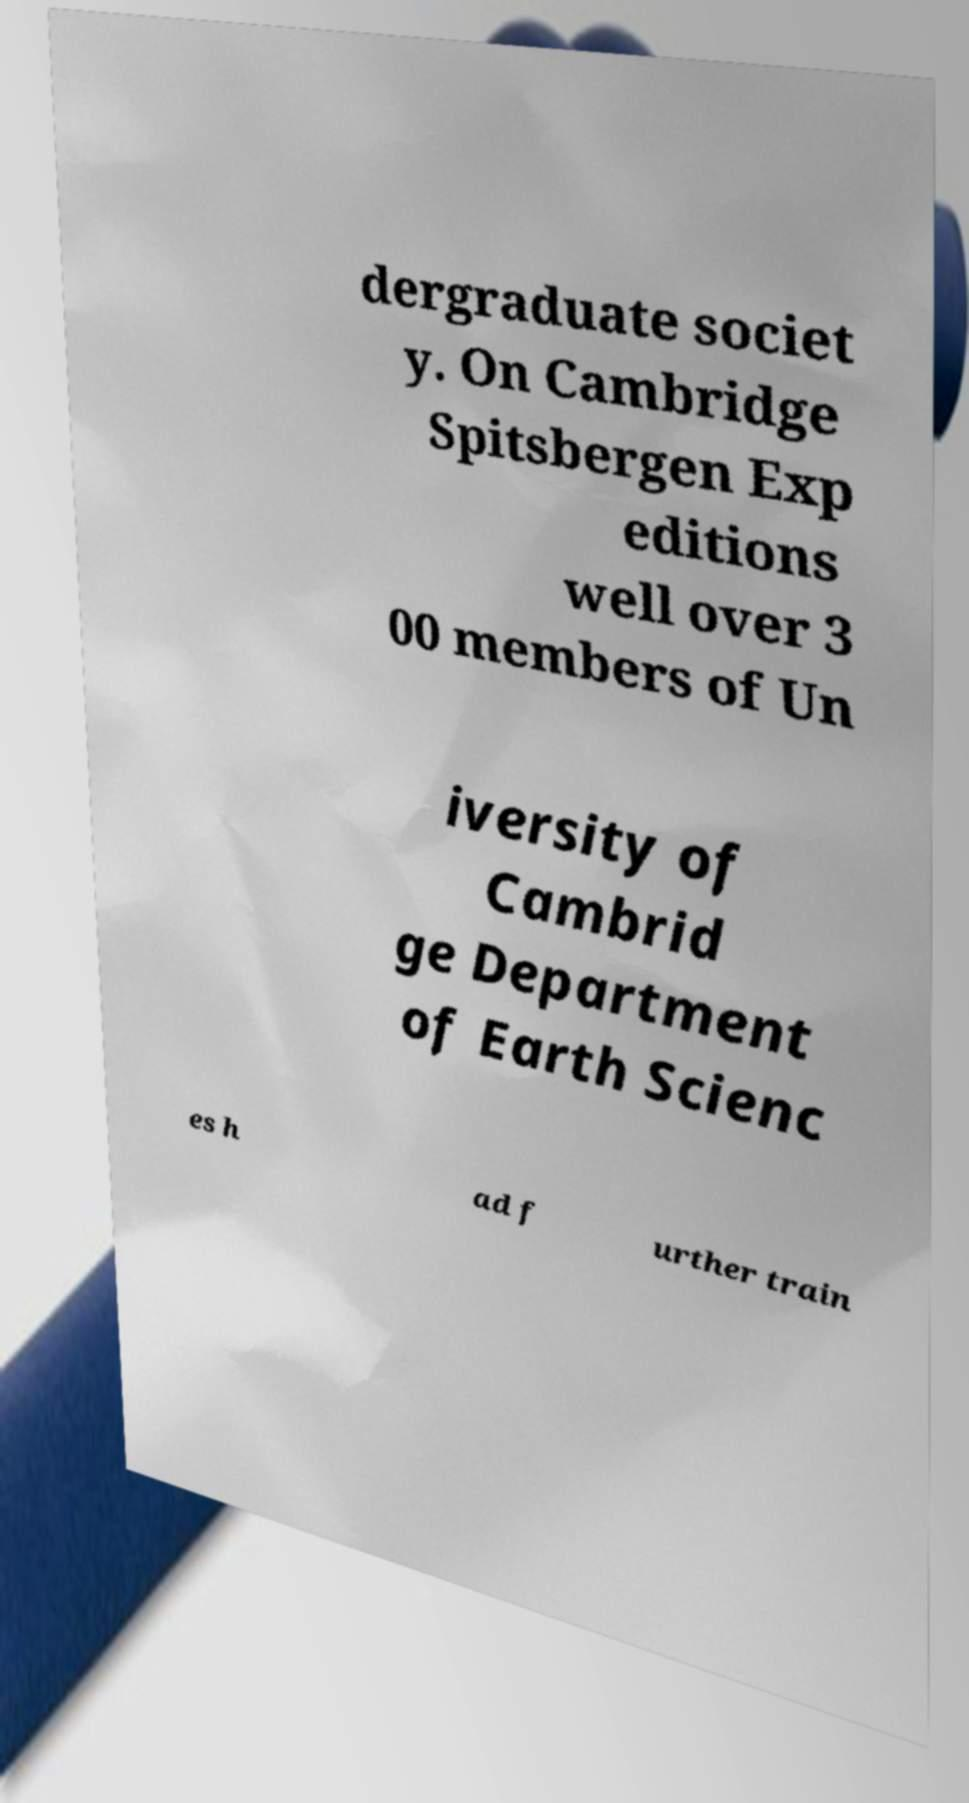What messages or text are displayed in this image? I need them in a readable, typed format. dergraduate societ y. On Cambridge Spitsbergen Exp editions well over 3 00 members of Un iversity of Cambrid ge Department of Earth Scienc es h ad f urther train 